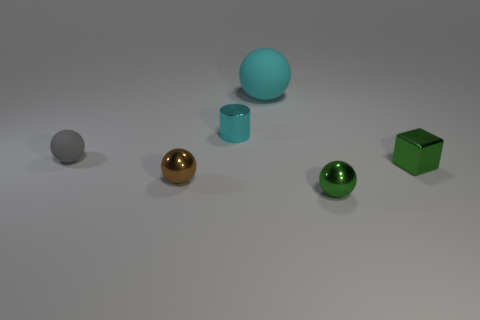What number of rubber things are either tiny brown spheres or small cyan cylinders?
Offer a terse response. 0. There is a matte object in front of the big cyan rubber sphere; is its shape the same as the cyan object in front of the large rubber sphere?
Ensure brevity in your answer.  No. There is a tiny metallic object that is both behind the tiny brown metallic ball and right of the tiny cyan metal thing; what is its color?
Make the answer very short. Green. Does the metallic thing behind the gray object have the same size as the rubber thing that is behind the tiny gray object?
Offer a very short reply. No. What number of matte things have the same color as the cylinder?
Your response must be concise. 1. How many tiny objects are shiny objects or cylinders?
Keep it short and to the point. 4. Do the small green thing that is behind the brown ball and the tiny gray ball have the same material?
Ensure brevity in your answer.  No. There is a ball that is right of the large matte sphere; what color is it?
Keep it short and to the point. Green. Are there any brown rubber balls of the same size as the cyan matte ball?
Keep it short and to the point. No. What is the material of the brown ball that is the same size as the green shiny sphere?
Make the answer very short. Metal. 